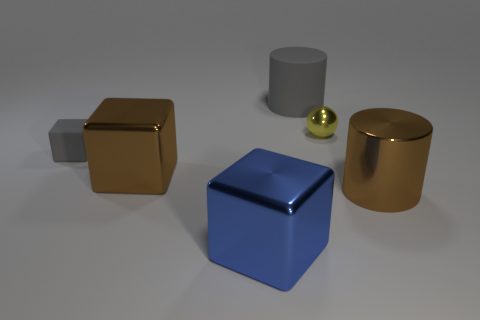Add 3 big rubber cylinders. How many objects exist? 9 Subtract all cylinders. How many objects are left? 4 Subtract all tiny yellow balls. Subtract all blue metallic objects. How many objects are left? 4 Add 1 brown objects. How many brown objects are left? 3 Add 2 yellow metal objects. How many yellow metal objects exist? 3 Subtract 0 purple blocks. How many objects are left? 6 